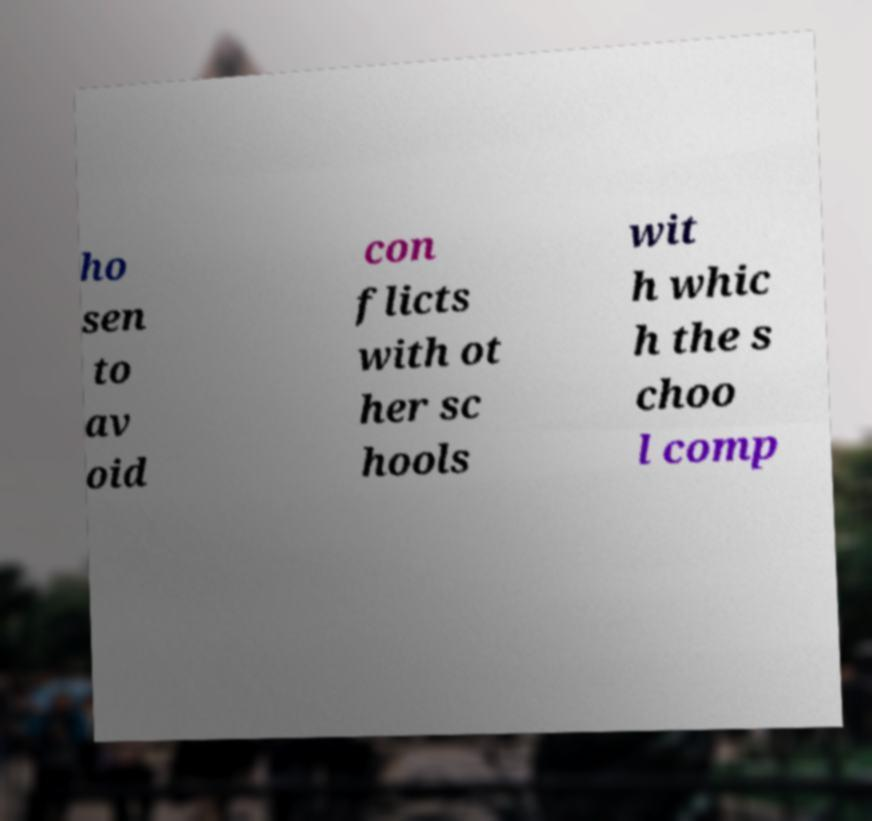For documentation purposes, I need the text within this image transcribed. Could you provide that? ho sen to av oid con flicts with ot her sc hools wit h whic h the s choo l comp 